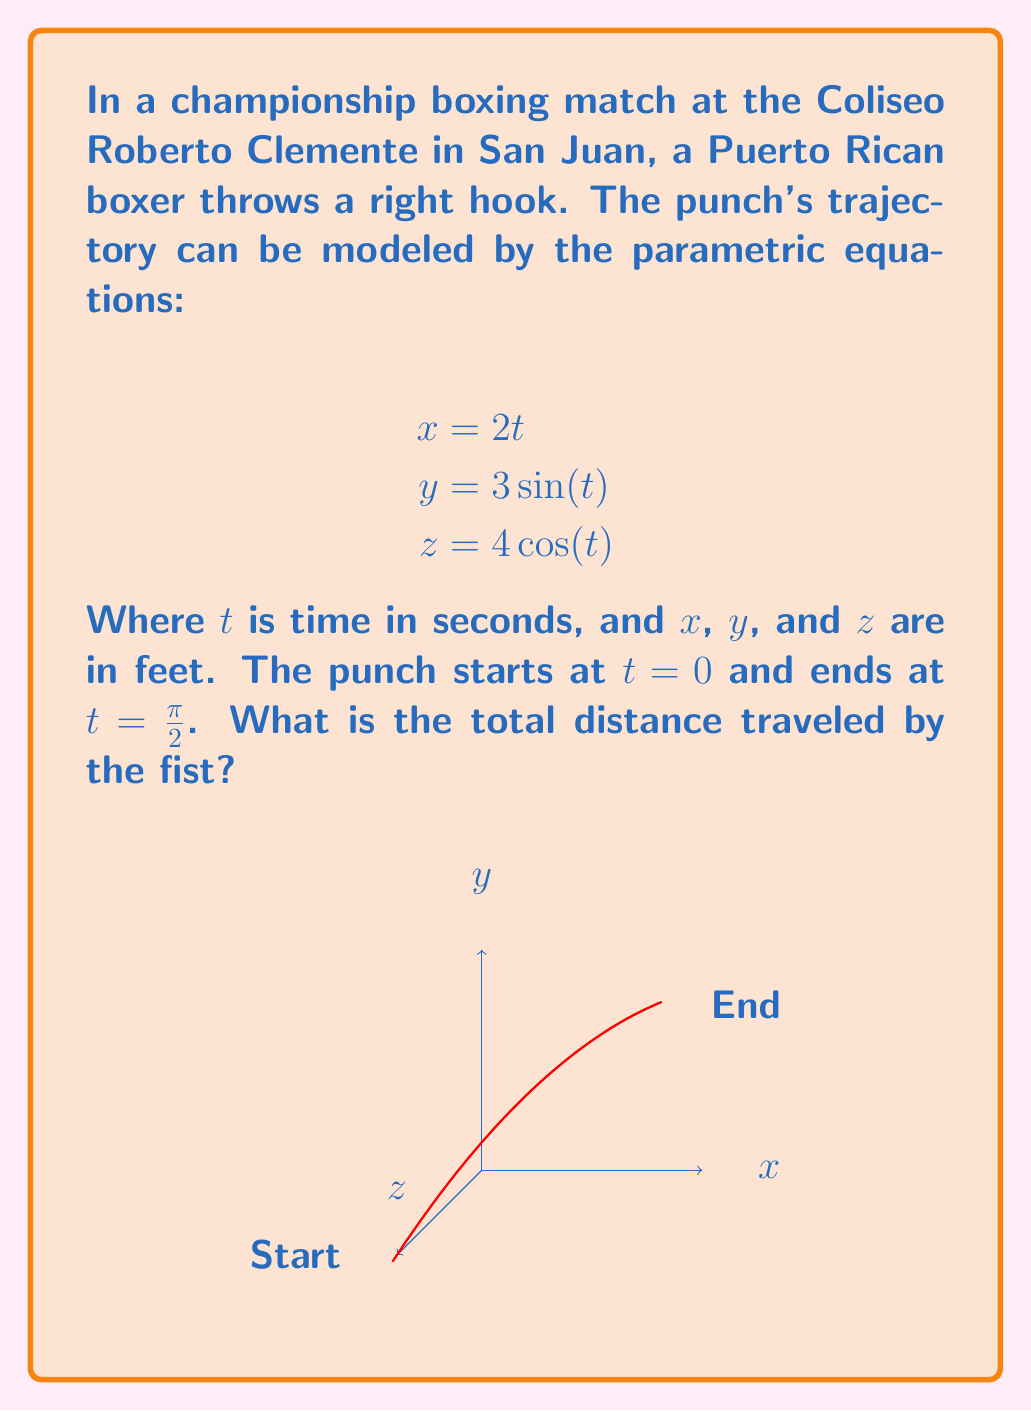Can you solve this math problem? Let's approach this step-by-step:

1) To find the total distance traveled, we need to calculate the arc length of the curve defined by the parametric equations.

2) The formula for arc length in 3D parametric equations is:

   $$L = \int_{a}^{b} \sqrt{\left(\frac{dx}{dt}\right)^2 + \left(\frac{dy}{dt}\right)^2 + \left(\frac{dz}{dt}\right)^2} dt$$

3) Let's find the derivatives:
   $$\frac{dx}{dt} = 2$$
   $$\frac{dy}{dt} = 3\cos(t)$$
   $$\frac{dz}{dt} = -4\sin(t)$$

4) Substituting these into the arc length formula:

   $$L = \int_{0}^{\frac{\pi}{2}} \sqrt{2^2 + (3\cos(t))^2 + (-4\sin(t))^2} dt$$

5) Simplify under the square root:

   $$L = \int_{0}^{\frac{\pi}{2}} \sqrt{4 + 9\cos^2(t) + 16\sin^2(t)} dt$$

6) Use the trigonometric identity $\cos^2(t) + \sin^2(t) = 1$:

   $$L = \int_{0}^{\frac{\pi}{2}} \sqrt{4 + 9\cos^2(t) + 16(1-\cos^2(t))} dt$$
   $$= \int_{0}^{\frac{\pi}{2}} \sqrt{20 - 7\cos^2(t)} dt$$

7) This integral doesn't have an elementary antiderivative. We need to use numerical integration methods or special functions to evaluate it.

8) Using numerical integration, we find:

   $$L \approx 5.545 \text{ feet}$$
Answer: $5.545$ feet 